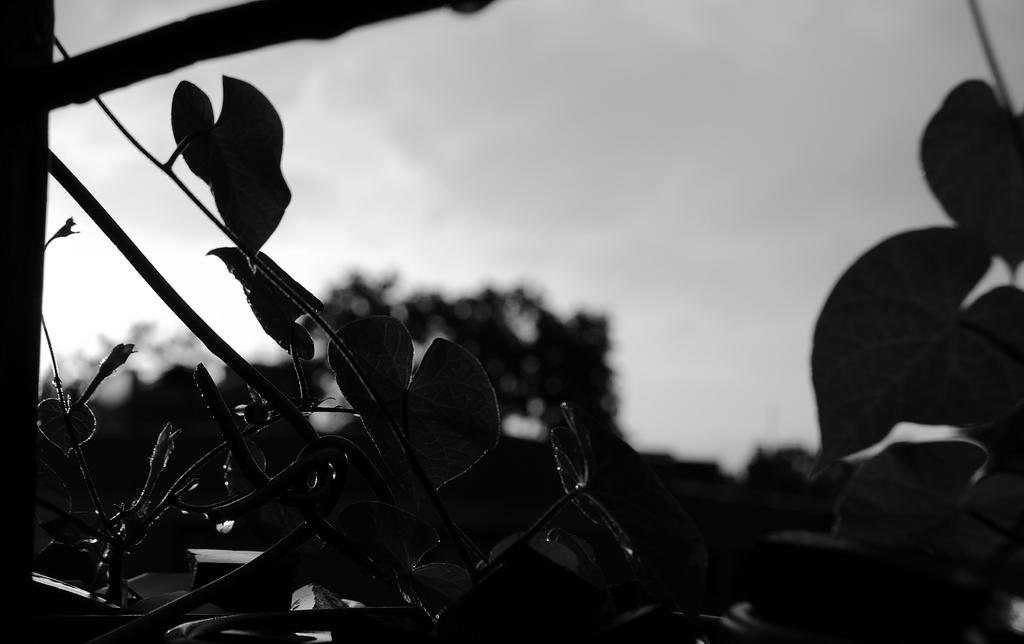What type of vegetation is present in the image? There are leafs and trees in the image. Can you describe the color scheme of the image? The image is black and white in color. What is the opinion of the trees in the image? There is no indication of an opinion in the image, as it is a visual representation of trees and leafs. 